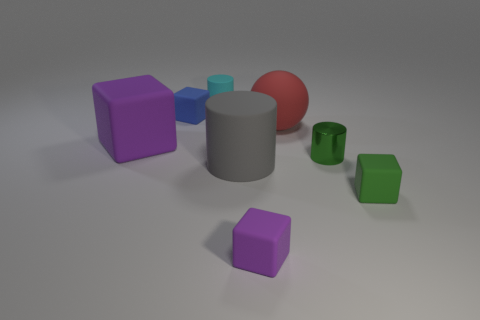Is the shape of the big red rubber object the same as the green metal object?
Offer a terse response. No. What is the color of the tiny cylinder that is behind the tiny green thing that is left of the small green cube?
Provide a succinct answer. Cyan. There is a block that is both in front of the small blue matte block and to the left of the small cyan object; what is its size?
Make the answer very short. Large. Is there anything else that has the same color as the metallic cylinder?
Give a very brief answer. Yes. The red thing that is the same material as the small blue thing is what shape?
Offer a very short reply. Sphere. There is a small blue rubber object; is it the same shape as the thing that is behind the small blue object?
Provide a succinct answer. No. What material is the cylinder that is on the left side of the rubber cylinder that is in front of the small green metal object?
Provide a short and direct response. Rubber. Are there the same number of tiny blue objects in front of the green cylinder and tiny purple metal objects?
Make the answer very short. Yes. Is there any other thing that has the same material as the blue cube?
Your answer should be compact. Yes. There is a tiny cylinder behind the small metallic thing; does it have the same color as the tiny thing that is to the left of the small cyan cylinder?
Ensure brevity in your answer.  No. 